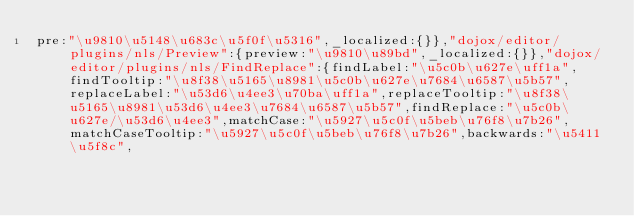<code> <loc_0><loc_0><loc_500><loc_500><_JavaScript_>pre:"\u9810\u5148\u683c\u5f0f\u5316",_localized:{}},"dojox/editor/plugins/nls/Preview":{preview:"\u9810\u89bd",_localized:{}},"dojox/editor/plugins/nls/FindReplace":{findLabel:"\u5c0b\u627e\uff1a",findTooltip:"\u8f38\u5165\u8981\u5c0b\u627e\u7684\u6587\u5b57",replaceLabel:"\u53d6\u4ee3\u70ba\uff1a",replaceTooltip:"\u8f38\u5165\u8981\u53d6\u4ee3\u7684\u6587\u5b57",findReplace:"\u5c0b\u627e/\u53d6\u4ee3",matchCase:"\u5927\u5c0f\u5beb\u76f8\u7b26",matchCaseTooltip:"\u5927\u5c0f\u5beb\u76f8\u7b26",backwards:"\u5411\u5f8c",</code> 